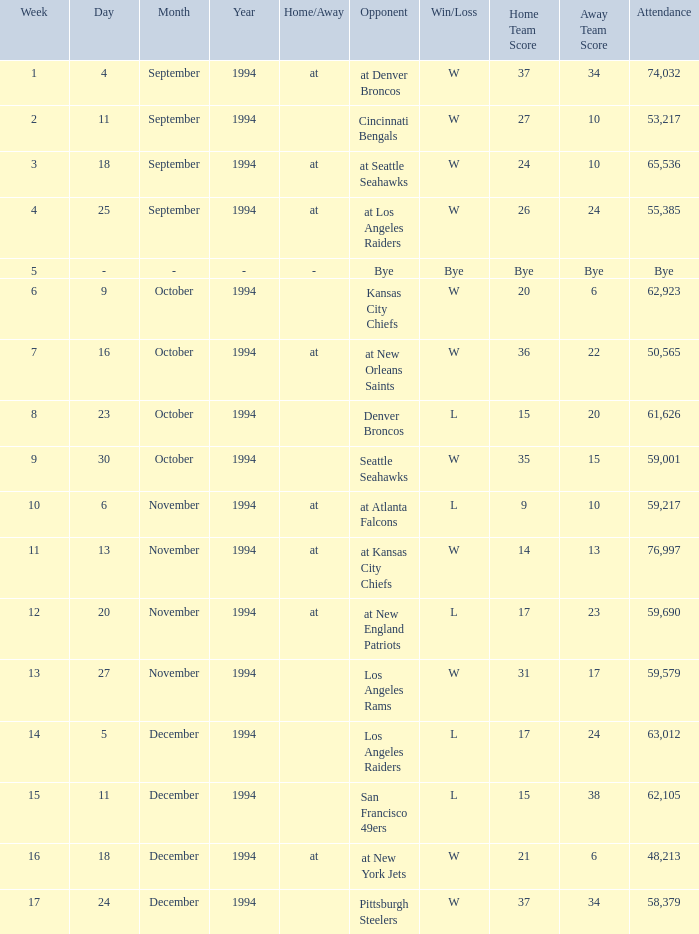In the game where they played the Pittsburgh Steelers, what was the attendance? 58379.0. 